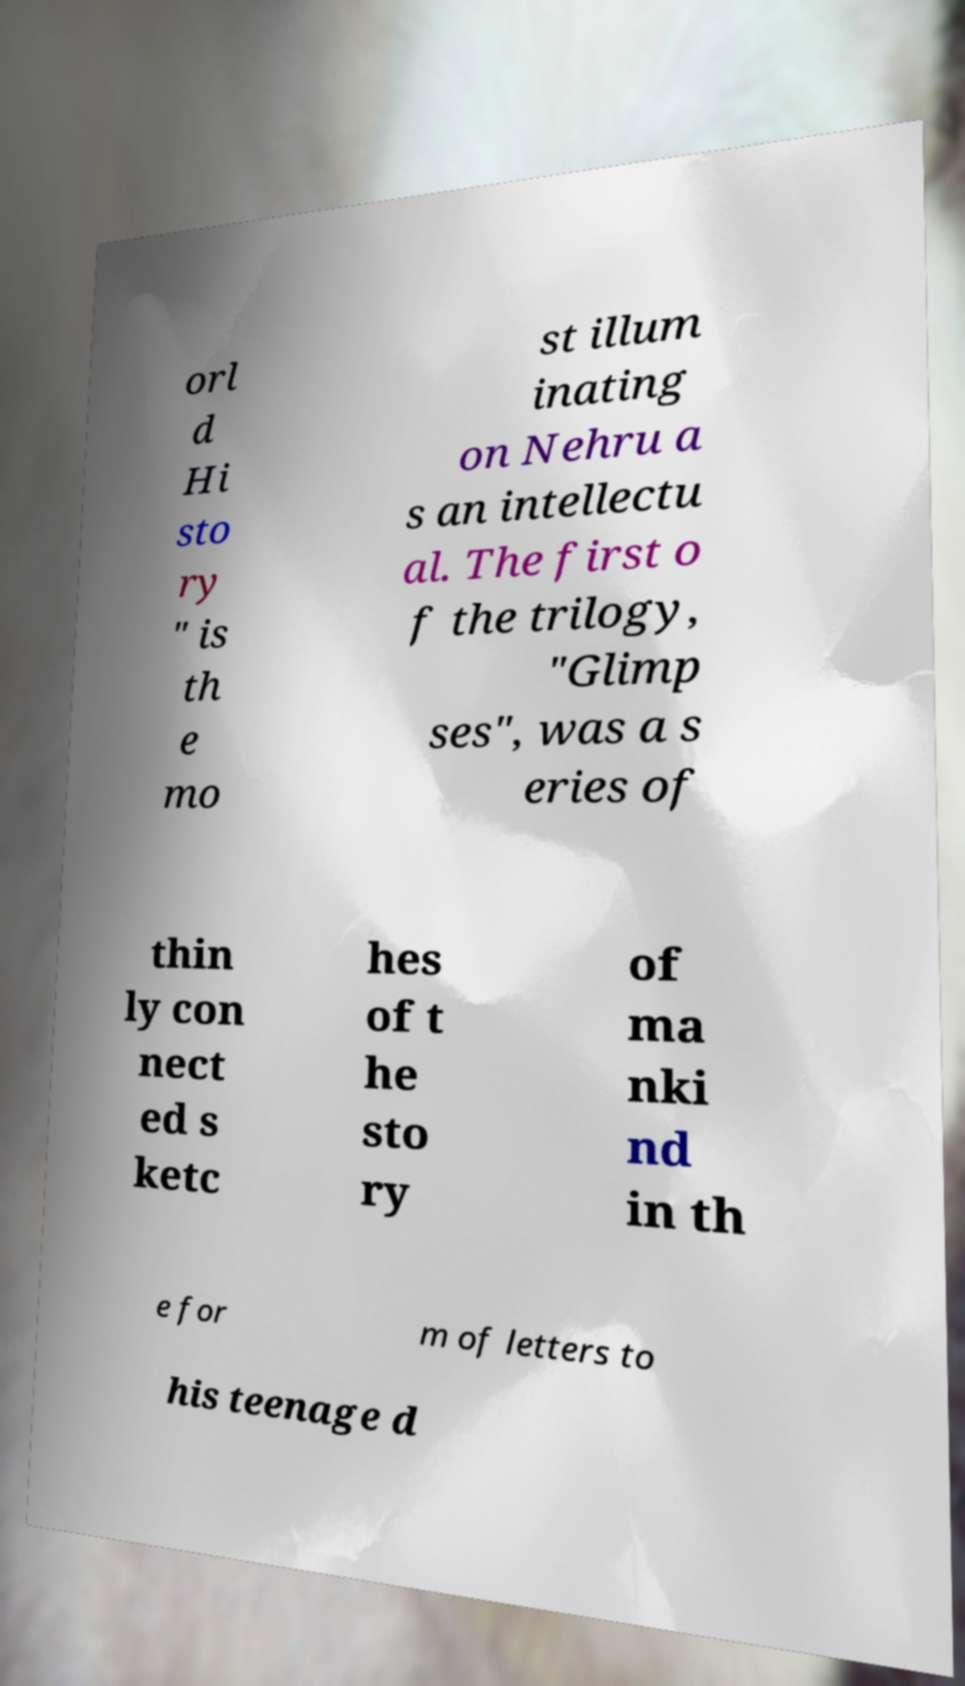Could you assist in decoding the text presented in this image and type it out clearly? orl d Hi sto ry " is th e mo st illum inating on Nehru a s an intellectu al. The first o f the trilogy, "Glimp ses", was a s eries of thin ly con nect ed s ketc hes of t he sto ry of ma nki nd in th e for m of letters to his teenage d 